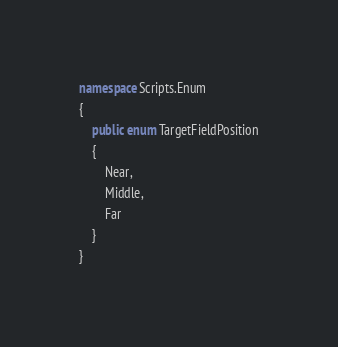<code> <loc_0><loc_0><loc_500><loc_500><_C#_>namespace Scripts.Enum
{
    public enum TargetFieldPosition
    {
        Near,
        Middle,
        Far
    }
}
</code> 